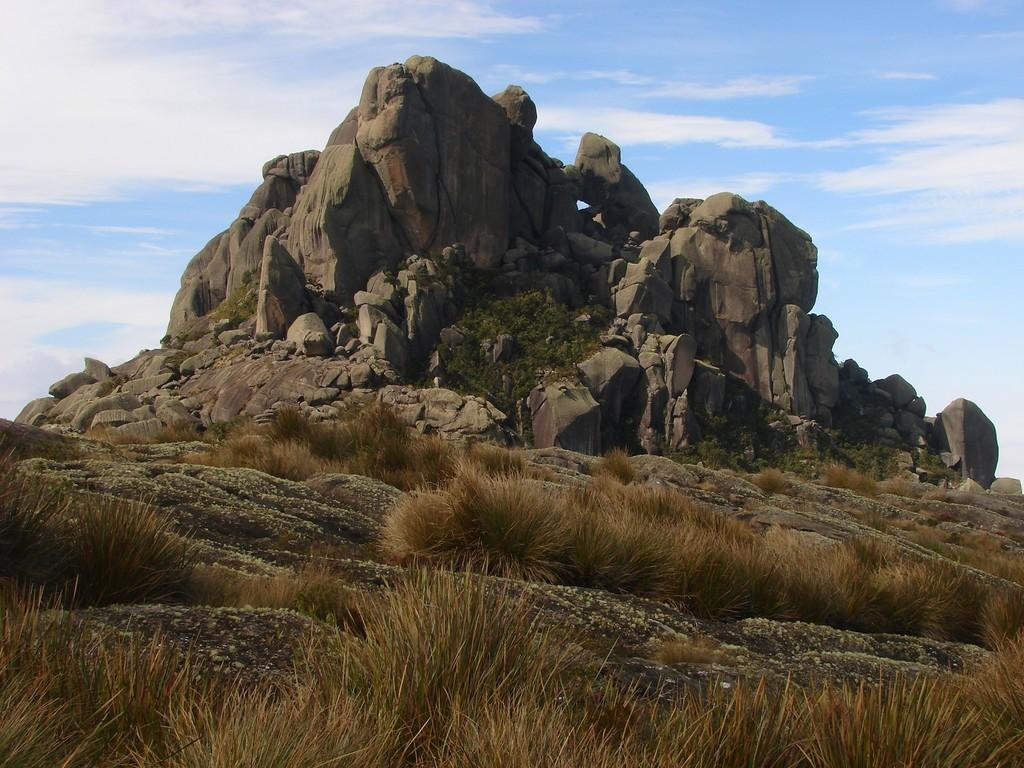What type of natural elements can be seen in the image? There are rocks and shrubs visible in the image. What is the surface on which the rocks and shrubs are located? The ground is visible in the image. What can be seen in the background of the image? The sky is visible in the background of the image. What is the condition of the sky in the image? Clouds are present in the sky. Can you see the tail of the animal in the image? There is no animal present in the image, so there is no tail to be seen. 